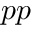<formula> <loc_0><loc_0><loc_500><loc_500>p p</formula> 